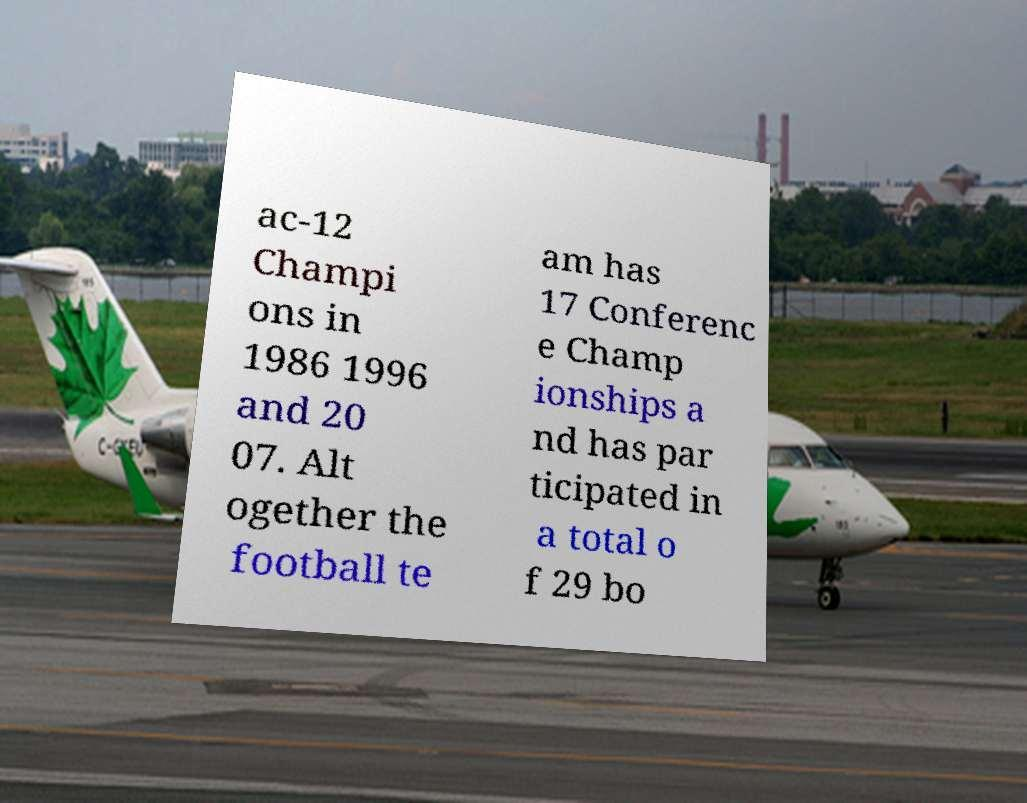Could you assist in decoding the text presented in this image and type it out clearly? ac-12 Champi ons in 1986 1996 and 20 07. Alt ogether the football te am has 17 Conferenc e Champ ionships a nd has par ticipated in a total o f 29 bo 